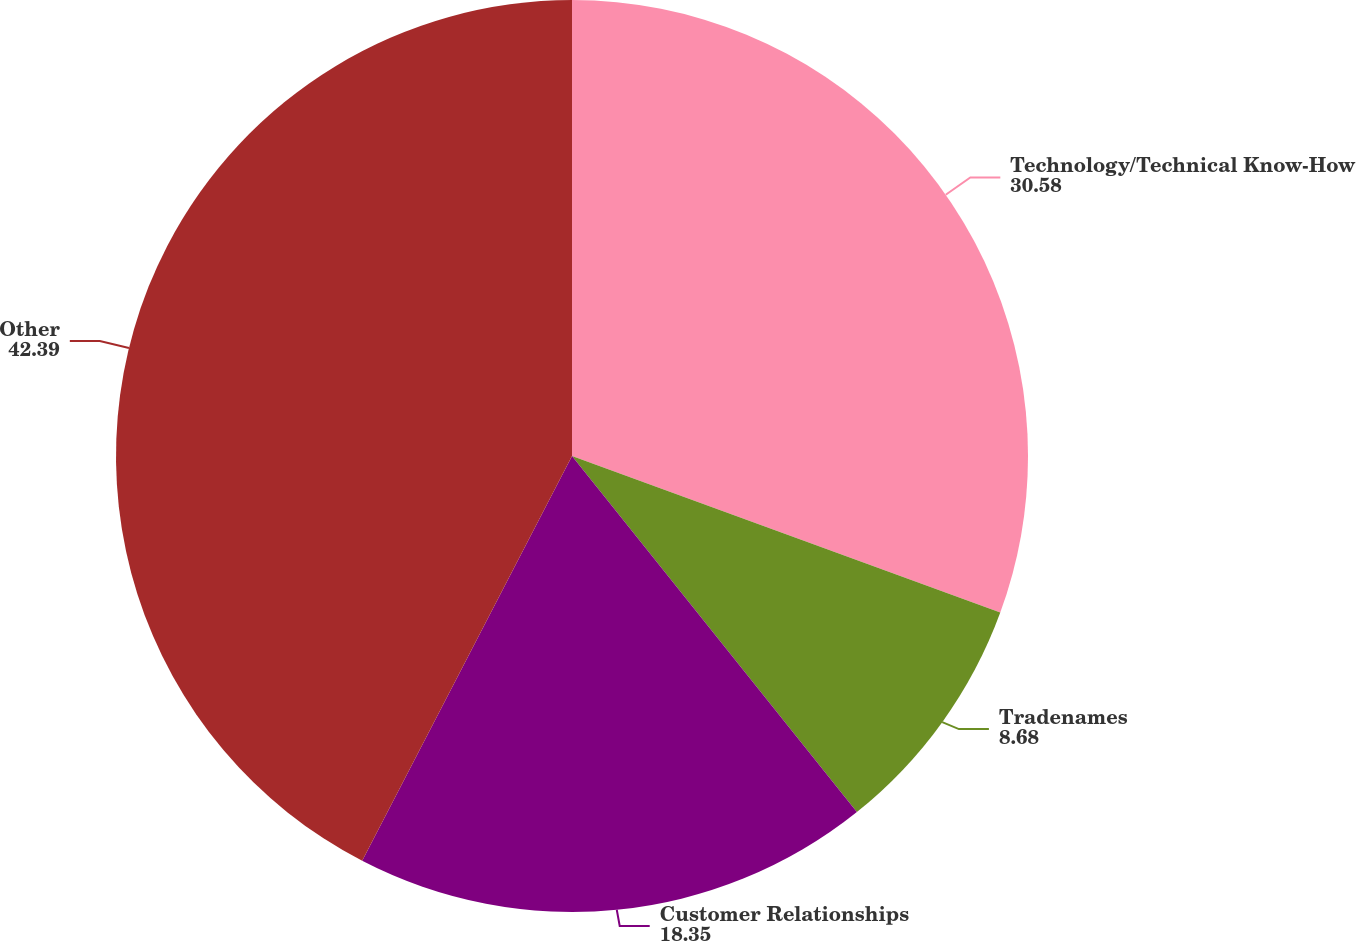Convert chart. <chart><loc_0><loc_0><loc_500><loc_500><pie_chart><fcel>Technology/Technical Know-How<fcel>Tradenames<fcel>Customer Relationships<fcel>Other<nl><fcel>30.58%<fcel>8.68%<fcel>18.35%<fcel>42.39%<nl></chart> 